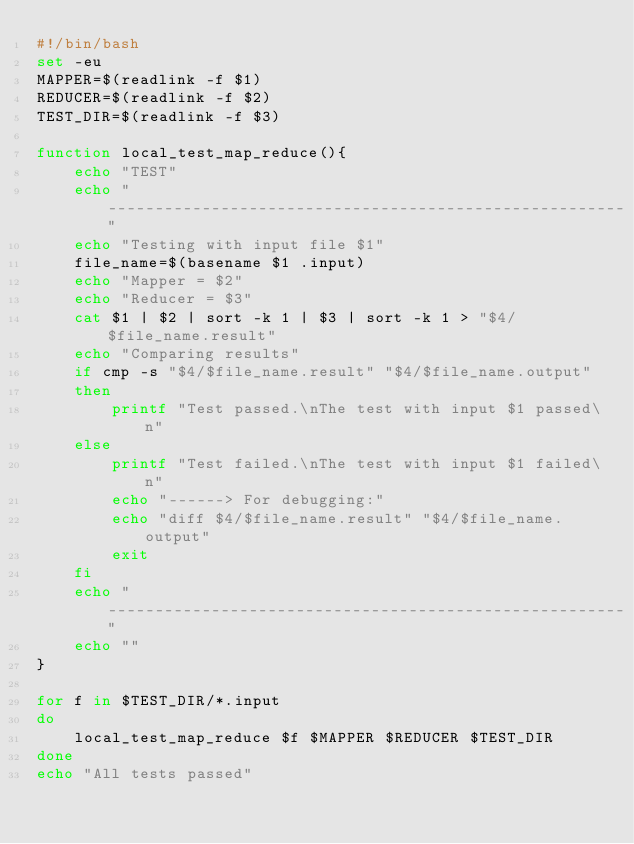Convert code to text. <code><loc_0><loc_0><loc_500><loc_500><_Bash_>#!/bin/bash
set -eu
MAPPER=$(readlink -f $1)
REDUCER=$(readlink -f $2)
TEST_DIR=$(readlink -f $3)

function local_test_map_reduce(){
	echo "TEST"
	echo "-------------------------------------------------------"
	echo "Testing with input file $1"
	file_name=$(basename $1 .input)
	echo "Mapper = $2"
	echo "Reducer = $3"
	cat $1 | $2 | sort -k 1 | $3 | sort -k 1 > "$4/$file_name.result"
	echo "Comparing results"
	if cmp -s "$4/$file_name.result" "$4/$file_name.output"
	then
		printf "Test passed.\nThe test with input $1 passed\n"
	else
		printf "Test failed.\nThe test with input $1 failed\n"
		echo "------> For debugging:"
		echo "diff $4/$file_name.result" "$4/$file_name.output"
		exit
	fi
	echo "-------------------------------------------------------"
	echo ""
}

for f in $TEST_DIR/*.input
do
	local_test_map_reduce $f $MAPPER $REDUCER $TEST_DIR	
done
echo "All tests passed"

</code> 